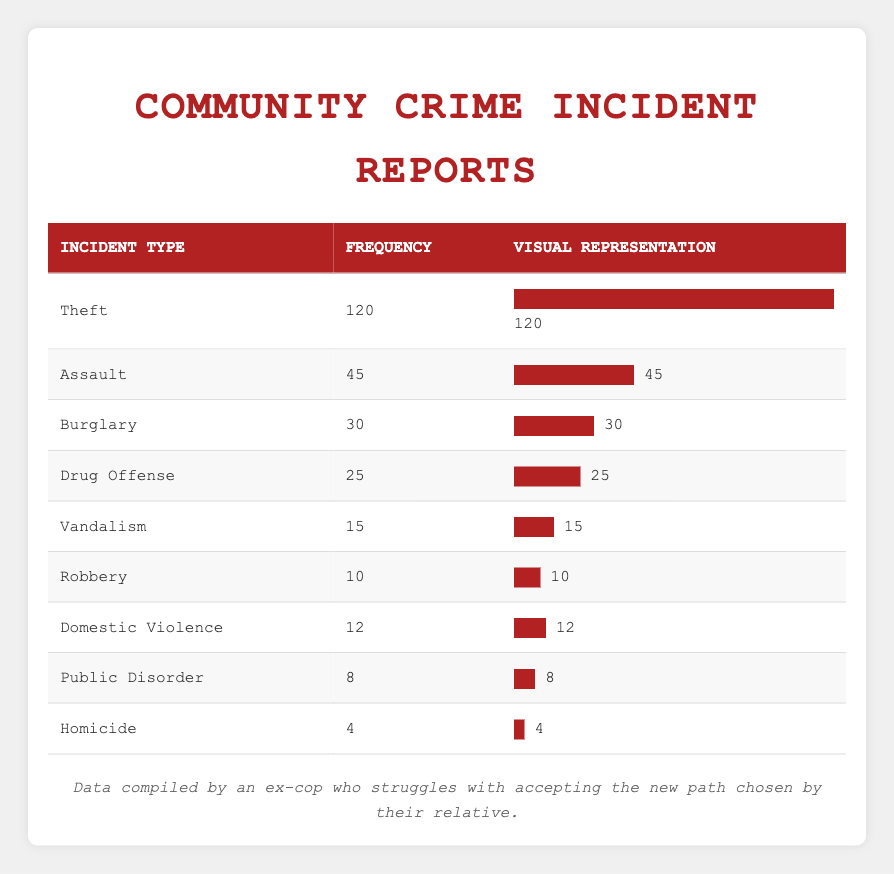What is the most frequent type of crime reported? The table shows that the highest frequency recorded for any incident type is 120 for Theft.
Answer: Theft How many incidents of Domestic Violence were reported? The table indicates that there were 12 incidents reported under the Domestic Violence category.
Answer: 12 What is the total number of crime incidents reported in the table? To find the total number of incidents, we need to sum the frequencies: 120 (Theft) + 45 (Assault) + 30 (Burglary) + 25 (Drug Offense) + 15 (Vandalism) + 10 (Robbery) + 12 (Domestic Violence) + 8 (Public Disorder) + 4 (Homicide) = 269.
Answer: 269 Is the number of reported Robberies greater than the number of Drug Offenses? According to the table, there are 10 reported Robberies and 25 Drug Offenses. Since 10 is less than 25, the statement is false.
Answer: No What percentage of the total incidents does Assault represent? First, calculate the total number of incidents (269). Then, divide the Assault frequency (45) by the total (269) and multiply by 100: (45/269) * 100 = approximately 16.7%.
Answer: 16.7% How does the frequency of Vandalism compare to that of Homicide? Vandalism has a frequency of 15 while Homicide has a frequency of 4. Since 15 is greater than 4, Vandalism has a higher frequency.
Answer: Vandalism is greater What is the difference in frequency between Theft and Burglary? The frequency of Theft is 120 and Burglary is 30. The difference is calculated as 120 - 30 = 90.
Answer: 90 Are there more than 40 reported Assault incidents? The table shows that there are 45 reported Assault incidents, which is greater than 40, making the statement true.
Answer: Yes 